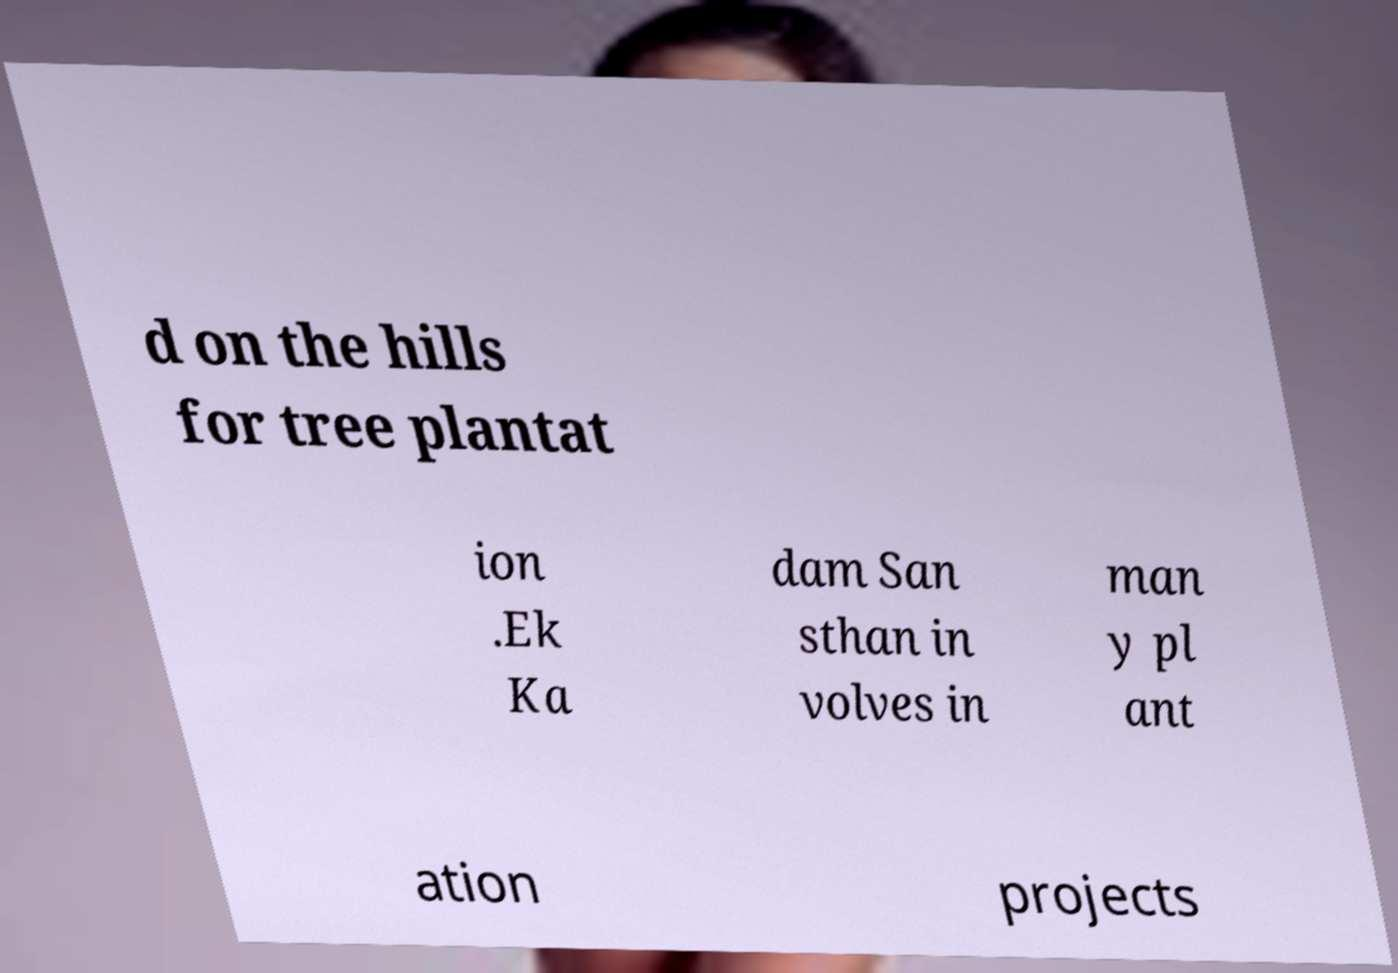Can you read and provide the text displayed in the image?This photo seems to have some interesting text. Can you extract and type it out for me? d on the hills for tree plantat ion .Ek Ka dam San sthan in volves in man y pl ant ation projects 